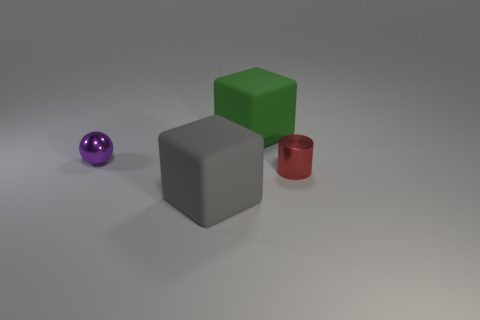Add 4 purple metal things. How many objects exist? 8 Subtract all spheres. How many objects are left? 3 Add 3 large green things. How many large green things are left? 4 Add 4 gray cubes. How many gray cubes exist? 5 Subtract 0 red spheres. How many objects are left? 4 Subtract all gray objects. Subtract all red objects. How many objects are left? 2 